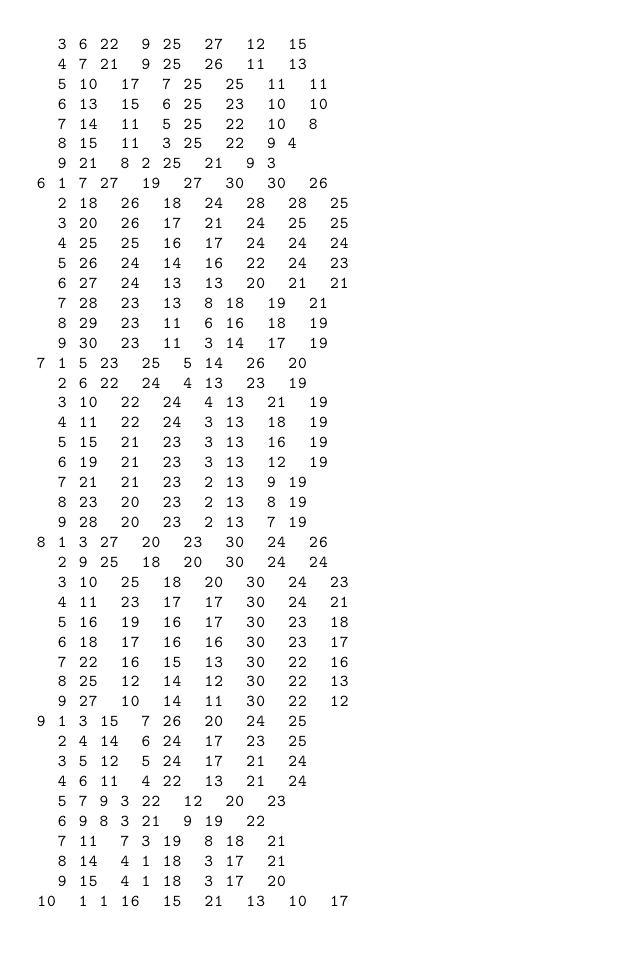<code> <loc_0><loc_0><loc_500><loc_500><_ObjectiveC_>	3	6	22	9	25	27	12	15	
	4	7	21	9	25	26	11	13	
	5	10	17	7	25	25	11	11	
	6	13	15	6	25	23	10	10	
	7	14	11	5	25	22	10	8	
	8	15	11	3	25	22	9	4	
	9	21	8	2	25	21	9	3	
6	1	7	27	19	27	30	30	26	
	2	18	26	18	24	28	28	25	
	3	20	26	17	21	24	25	25	
	4	25	25	16	17	24	24	24	
	5	26	24	14	16	22	24	23	
	6	27	24	13	13	20	21	21	
	7	28	23	13	8	18	19	21	
	8	29	23	11	6	16	18	19	
	9	30	23	11	3	14	17	19	
7	1	5	23	25	5	14	26	20	
	2	6	22	24	4	13	23	19	
	3	10	22	24	4	13	21	19	
	4	11	22	24	3	13	18	19	
	5	15	21	23	3	13	16	19	
	6	19	21	23	3	13	12	19	
	7	21	21	23	2	13	9	19	
	8	23	20	23	2	13	8	19	
	9	28	20	23	2	13	7	19	
8	1	3	27	20	23	30	24	26	
	2	9	25	18	20	30	24	24	
	3	10	25	18	20	30	24	23	
	4	11	23	17	17	30	24	21	
	5	16	19	16	17	30	23	18	
	6	18	17	16	16	30	23	17	
	7	22	16	15	13	30	22	16	
	8	25	12	14	12	30	22	13	
	9	27	10	14	11	30	22	12	
9	1	3	15	7	26	20	24	25	
	2	4	14	6	24	17	23	25	
	3	5	12	5	24	17	21	24	
	4	6	11	4	22	13	21	24	
	5	7	9	3	22	12	20	23	
	6	9	8	3	21	9	19	22	
	7	11	7	3	19	8	18	21	
	8	14	4	1	18	3	17	21	
	9	15	4	1	18	3	17	20	
10	1	1	16	15	21	13	10	17	</code> 